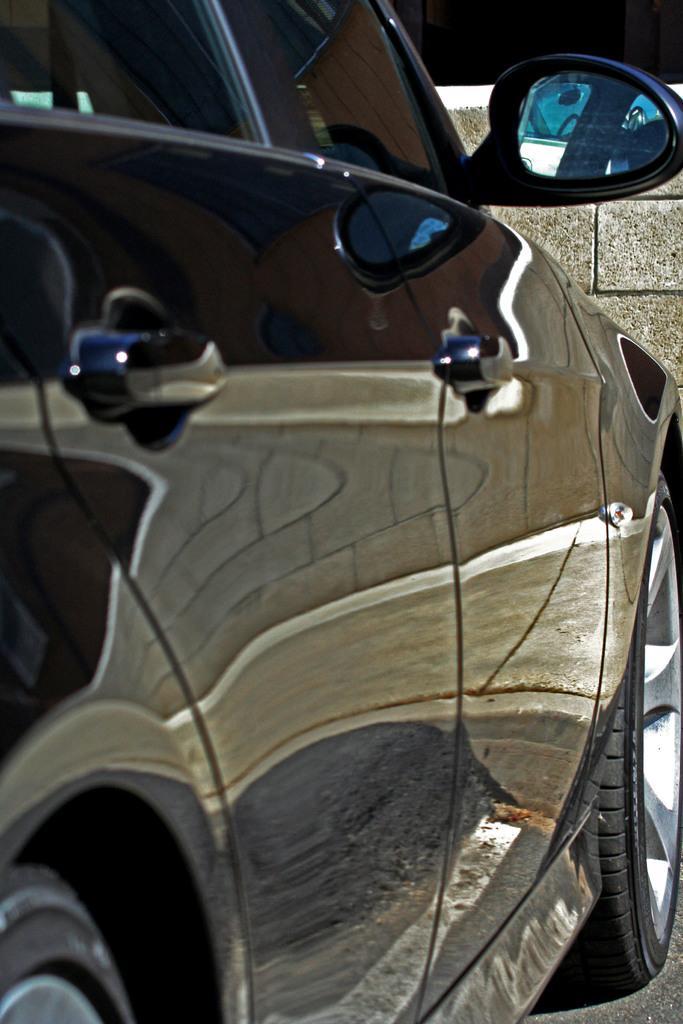Can you describe this image briefly? Here we can see a car which is truncated. 